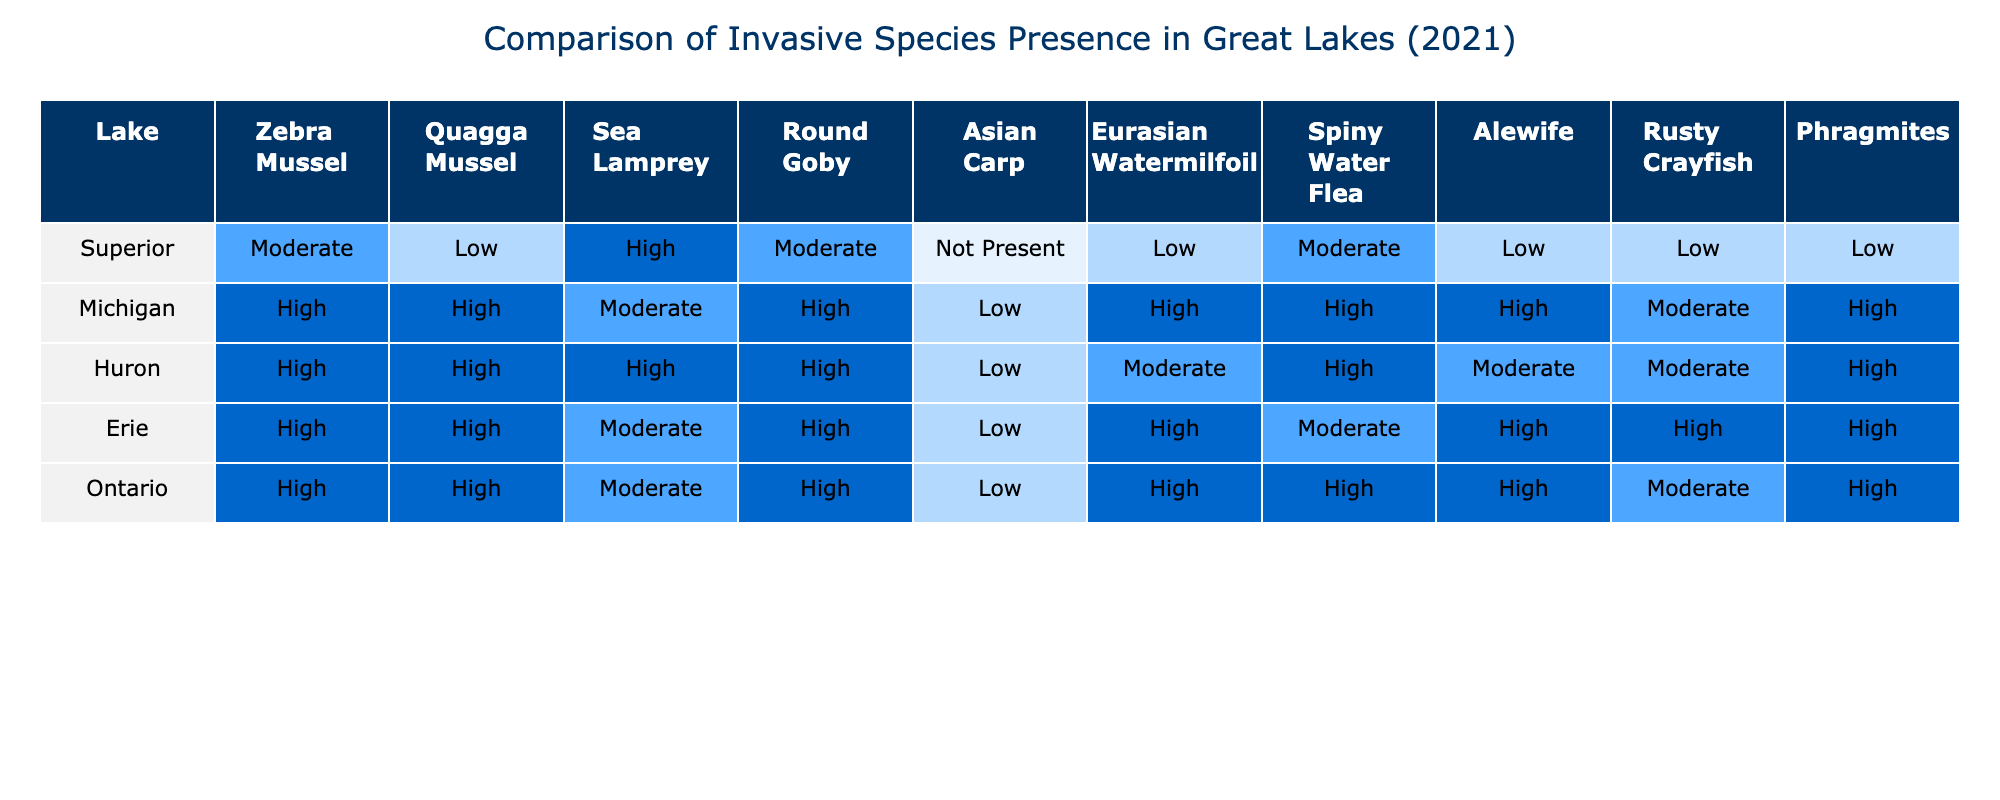What invasive species has the highest presence in Lake Michigan? In the table, I locate Lake Michigan and look for the species with the highest presence rating in its row. The row shows "Zebra Mussel" and "Quagga Mussel" both listed as "High". However, based on the question for the highest presence without tie consideration, I can choose either.
Answer: Zebra Mussel or Quagga Mussel Which Great Lake has a 'Not Present' status for Asian Carp? Checking the table, I look at the Asian Carp column across all lakes. The only lake showing "Not Present" is Lake Superior.
Answer: Lake Superior Which invasive species are present in all five lakes? I analyze each row to identify species that have at least "Low" presence across all lakes. The species "Zebra Mussel," "Quagga Mussel," "Sea Lamprey," and "Round Goby" are noted to be present in at least some capacity across all lakes.
Answer: Zebra Mussel, Quagga Mussel, Sea Lamprey, Round Goby Is there any lake where Eurasian Watermilfoil is ranked as 'Low'? I look for the Eurasian Watermilfoil row across all lakes. Lake Superior is listed as "Low," confirming the presence of this species at that level.
Answer: Yes What is the cumulative presence of Rusty Crayfish in all lakes combined? I locate the Rusty Crayfish column and note the presence ranks: Low for Superior (1), High for Michigan (3), High for Huron (3), High for Erie (3), and Moderate for Ontario (2). The total presence ranks calculated as 1 + 3 + 3 + 3 + 2 equals 12.
Answer: 12 How does the presence of Spiny Water Flea compare between Lake Erie and Lake Huron? The table shows Lake Erie has a "High" presence while Lake Huron has a "Moderate" presence. Comparing these ratings indicates that Spiny Water Flea is more prevalent in Lake Erie.
Answer: More prevalent in Lake Erie Which two lakes have the same status for Alewife? I check the Alewife column, and upon reviewing the rows, both Lake Huron and Lake Ontario show "High" presence.
Answer: Lake Huron and Lake Ontario What is the average presence ranking of invasive species in Lake Erie? Evaluating Lake Erie, the present species scores are High (3), High (3), Moderate (2), High (3), Low (1). The scores sum to 12, with 5 species. The average calculated is 12/5 = 2.4.
Answer: 2.4 Are there any invasive species that are classified as 'Moderate' in Lake Superior? I examine the row for Lake Superior. It shows "Moderate" for Zebra Mussel, Sea Lamprey, and Alewife, confirming the presence of invasive species at a 'Moderate' ranking.
Answer: Yes Which lake has the highest number of invasive species listed as 'High'? Scanning the presence ranks in the lakes, I see Lake Michigan and Lake Huron show four species listed as 'High' each. Thus, both lakes can be identified as having the highest count.
Answer: Lake Michigan and Lake Huron 